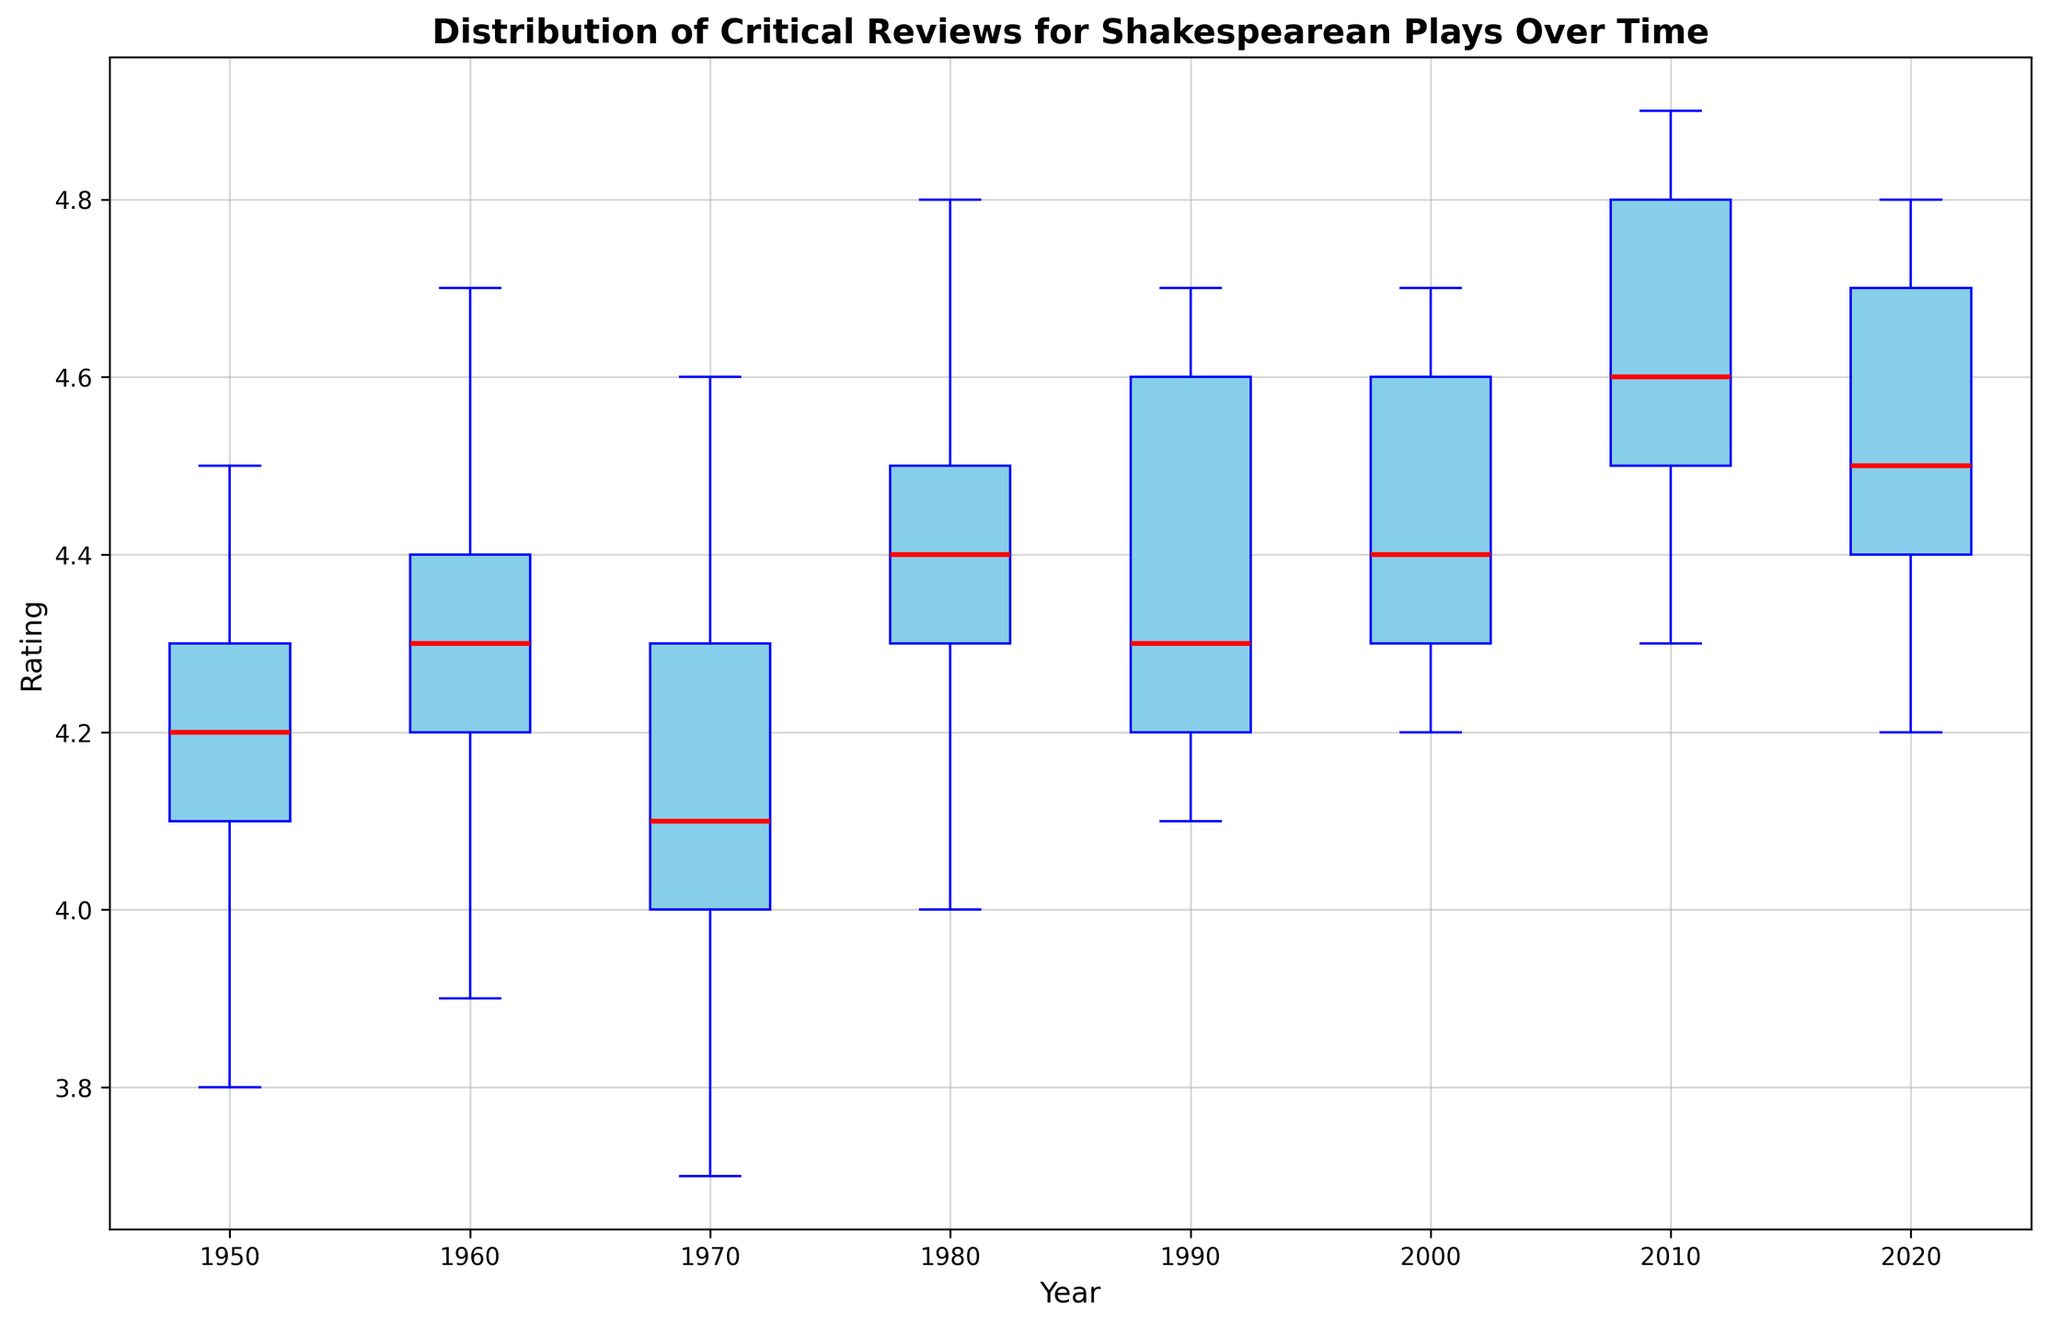What's the median rating for the year 2000? Locate the box for the year 2000 on the x-axis and find the red line inside the box (the median). The median represents the middle value of the data distribution.
Answer: 4.3 Which year has the highest median rating? Compare the median lines (red lines) for each year. The year with the highest median line represents the highest median rating.
Answer: 2010 Is the median rating of "Macbeth" increasing or decreasing over time? By examining the red median lines in each box, and knowing all the plays were rated similarly in each year; we find "Macbeth" shares the observed trend. Here, from 1950 to 2010, the median lines show an increasing trend.
Answer: Increasing For the year 1980, what is the range of ratings? Identify the boxplot for 1980 and estimate the values at the ends of the whiskers (minimum and maximum). Subtraction of these values gives the range.
Answer: 4.8 - 4.0 = 0.8 In which year did "Hamlet" have its highest rating, and what was that rating? Locate the highest individual rating for "Hamlet" within the box plots. Since "Hamlet" shares the data ranges, look for 2010 where the median and maximum values are highest. The maximum rating for "Hamlet" follows accordingly.
Answer: 2010, 4.9 Which play has the highest consistency in ratings over the years? Examine the width of the boxes and length of whiskers for each year. A consistent play will have smaller box widths and shorter whiskers.
Answer: "Much Ado About Nothing" (least variation observed) Was there an increasing trend in median ratings over time? Observe the trend of the median lines (red) for each year. Check if they show an upward trajectory from left (1950) to right (2020).
Answer: Yes Compare the spread of ratings in 1950 and 2020. Which year shows a greater spread? Look at the length of the whiskers in the boxplots for 1950 and 2020. The longer the whiskers, the greater the spread.
Answer: 1950 What was the interquartile range (IQR) for ratings in 2010? Identify the boxplot for 2010 and note the top (Q3) and bottom (Q1) of the box. Subtract the value of the bottom line (Q1) from the top line (Q3) of the box.
Answer: 4.8 - 4.5 = 0.3 Did any of the years show any outliers in ratings? Outliers are typically shown as individual points outside the whiskers in a boxplot. Check for any such points in any of the years.
Answer: No 